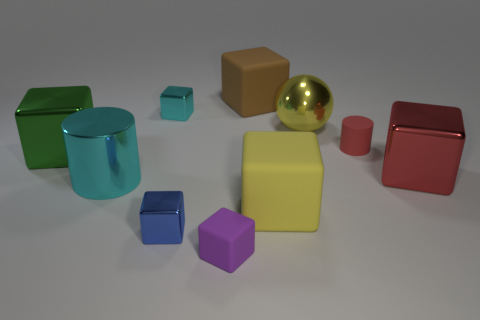The small cyan metal thing that is to the right of the large metal block to the left of the big red metal block is what shape?
Offer a terse response. Cube. What color is the small matte cylinder?
Your response must be concise. Red. What number of other things are the same size as the blue shiny cube?
Offer a terse response. 3. The small object that is in front of the big yellow metallic sphere and behind the yellow rubber cube is made of what material?
Offer a terse response. Rubber. There is a matte block that is to the right of the brown cube; is it the same size as the cyan metallic cylinder?
Keep it short and to the point. Yes. Do the tiny matte cylinder and the big metal sphere have the same color?
Provide a succinct answer. No. What number of cubes are both to the left of the purple object and right of the small cyan metallic cube?
Ensure brevity in your answer.  1. What number of small blue shiny things are in front of the large block that is on the right side of the small rubber thing that is to the right of the yellow ball?
Make the answer very short. 1. There is a metal thing that is the same color as the large cylinder; what is its size?
Offer a terse response. Small. There is a large brown thing; what shape is it?
Give a very brief answer. Cube. 